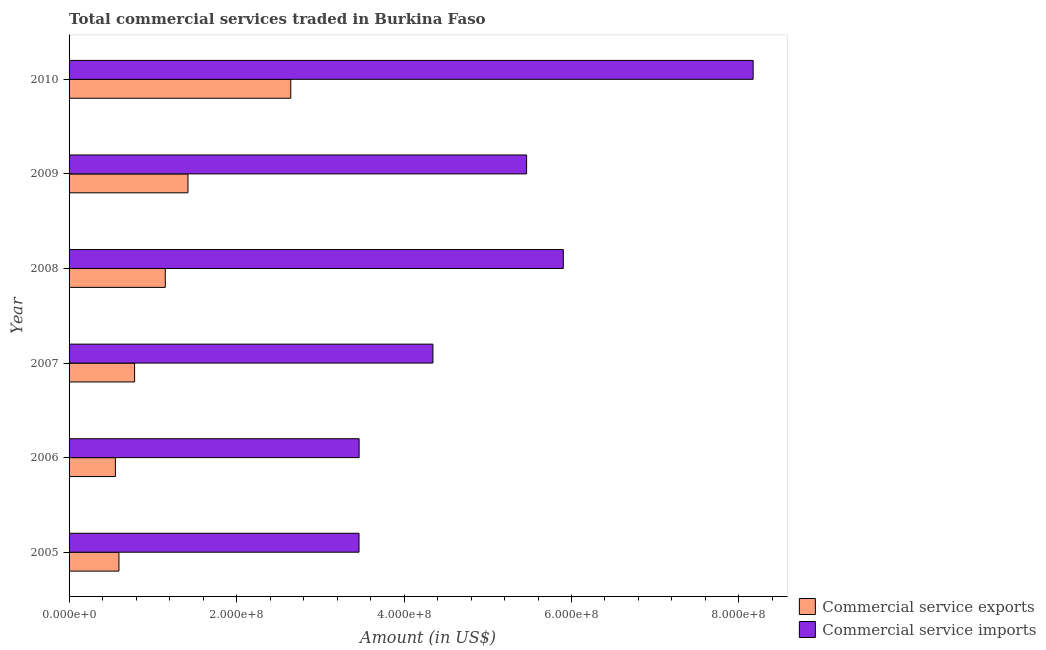How many different coloured bars are there?
Keep it short and to the point. 2. Are the number of bars per tick equal to the number of legend labels?
Your response must be concise. Yes. How many bars are there on the 3rd tick from the bottom?
Your response must be concise. 2. What is the label of the 6th group of bars from the top?
Offer a very short reply. 2005. In how many cases, is the number of bars for a given year not equal to the number of legend labels?
Your answer should be compact. 0. What is the amount of commercial service imports in 2006?
Your answer should be very brief. 3.46e+08. Across all years, what is the maximum amount of commercial service exports?
Ensure brevity in your answer.  2.65e+08. Across all years, what is the minimum amount of commercial service imports?
Your answer should be very brief. 3.46e+08. In which year was the amount of commercial service imports maximum?
Give a very brief answer. 2010. What is the total amount of commercial service imports in the graph?
Your response must be concise. 3.08e+09. What is the difference between the amount of commercial service imports in 2008 and that in 2009?
Your answer should be very brief. 4.38e+07. What is the difference between the amount of commercial service exports in 2008 and the amount of commercial service imports in 2005?
Your response must be concise. -2.31e+08. What is the average amount of commercial service exports per year?
Your answer should be compact. 1.19e+08. In the year 2005, what is the difference between the amount of commercial service exports and amount of commercial service imports?
Ensure brevity in your answer.  -2.87e+08. In how many years, is the amount of commercial service imports greater than 40000000 US$?
Offer a terse response. 6. What is the ratio of the amount of commercial service exports in 2007 to that in 2010?
Give a very brief answer. 0.3. What is the difference between the highest and the second highest amount of commercial service imports?
Offer a very short reply. 2.27e+08. What is the difference between the highest and the lowest amount of commercial service imports?
Keep it short and to the point. 4.71e+08. What does the 1st bar from the top in 2006 represents?
Provide a succinct answer. Commercial service imports. What does the 1st bar from the bottom in 2010 represents?
Offer a very short reply. Commercial service exports. Are all the bars in the graph horizontal?
Ensure brevity in your answer.  Yes. What is the difference between two consecutive major ticks on the X-axis?
Give a very brief answer. 2.00e+08. Does the graph contain any zero values?
Offer a very short reply. No. Where does the legend appear in the graph?
Offer a terse response. Bottom right. How many legend labels are there?
Your answer should be very brief. 2. What is the title of the graph?
Offer a very short reply. Total commercial services traded in Burkina Faso. What is the Amount (in US$) in Commercial service exports in 2005?
Your answer should be very brief. 5.95e+07. What is the Amount (in US$) in Commercial service imports in 2005?
Make the answer very short. 3.46e+08. What is the Amount (in US$) in Commercial service exports in 2006?
Your answer should be very brief. 5.53e+07. What is the Amount (in US$) in Commercial service imports in 2006?
Offer a very short reply. 3.46e+08. What is the Amount (in US$) of Commercial service exports in 2007?
Your answer should be very brief. 7.83e+07. What is the Amount (in US$) in Commercial service imports in 2007?
Your answer should be very brief. 4.35e+08. What is the Amount (in US$) in Commercial service exports in 2008?
Your response must be concise. 1.15e+08. What is the Amount (in US$) of Commercial service imports in 2008?
Ensure brevity in your answer.  5.90e+08. What is the Amount (in US$) of Commercial service exports in 2009?
Provide a succinct answer. 1.42e+08. What is the Amount (in US$) in Commercial service imports in 2009?
Offer a terse response. 5.46e+08. What is the Amount (in US$) of Commercial service exports in 2010?
Ensure brevity in your answer.  2.65e+08. What is the Amount (in US$) of Commercial service imports in 2010?
Ensure brevity in your answer.  8.17e+08. Across all years, what is the maximum Amount (in US$) in Commercial service exports?
Offer a very short reply. 2.65e+08. Across all years, what is the maximum Amount (in US$) of Commercial service imports?
Offer a terse response. 8.17e+08. Across all years, what is the minimum Amount (in US$) in Commercial service exports?
Provide a short and direct response. 5.53e+07. Across all years, what is the minimum Amount (in US$) in Commercial service imports?
Provide a succinct answer. 3.46e+08. What is the total Amount (in US$) of Commercial service exports in the graph?
Ensure brevity in your answer.  7.15e+08. What is the total Amount (in US$) of Commercial service imports in the graph?
Give a very brief answer. 3.08e+09. What is the difference between the Amount (in US$) of Commercial service exports in 2005 and that in 2006?
Offer a very short reply. 4.23e+06. What is the difference between the Amount (in US$) in Commercial service imports in 2005 and that in 2006?
Make the answer very short. -1.38e+05. What is the difference between the Amount (in US$) of Commercial service exports in 2005 and that in 2007?
Offer a very short reply. -1.87e+07. What is the difference between the Amount (in US$) of Commercial service imports in 2005 and that in 2007?
Provide a short and direct response. -8.83e+07. What is the difference between the Amount (in US$) in Commercial service exports in 2005 and that in 2008?
Your answer should be very brief. -5.54e+07. What is the difference between the Amount (in US$) in Commercial service imports in 2005 and that in 2008?
Your response must be concise. -2.44e+08. What is the difference between the Amount (in US$) of Commercial service exports in 2005 and that in 2009?
Offer a very short reply. -8.24e+07. What is the difference between the Amount (in US$) in Commercial service imports in 2005 and that in 2009?
Ensure brevity in your answer.  -2.00e+08. What is the difference between the Amount (in US$) of Commercial service exports in 2005 and that in 2010?
Your answer should be very brief. -2.05e+08. What is the difference between the Amount (in US$) in Commercial service imports in 2005 and that in 2010?
Make the answer very short. -4.71e+08. What is the difference between the Amount (in US$) of Commercial service exports in 2006 and that in 2007?
Keep it short and to the point. -2.29e+07. What is the difference between the Amount (in US$) of Commercial service imports in 2006 and that in 2007?
Offer a very short reply. -8.81e+07. What is the difference between the Amount (in US$) of Commercial service exports in 2006 and that in 2008?
Ensure brevity in your answer.  -5.96e+07. What is the difference between the Amount (in US$) in Commercial service imports in 2006 and that in 2008?
Your response must be concise. -2.44e+08. What is the difference between the Amount (in US$) in Commercial service exports in 2006 and that in 2009?
Give a very brief answer. -8.67e+07. What is the difference between the Amount (in US$) of Commercial service imports in 2006 and that in 2009?
Offer a very short reply. -2.00e+08. What is the difference between the Amount (in US$) of Commercial service exports in 2006 and that in 2010?
Give a very brief answer. -2.09e+08. What is the difference between the Amount (in US$) in Commercial service imports in 2006 and that in 2010?
Your response must be concise. -4.71e+08. What is the difference between the Amount (in US$) of Commercial service exports in 2007 and that in 2008?
Your answer should be compact. -3.66e+07. What is the difference between the Amount (in US$) of Commercial service imports in 2007 and that in 2008?
Your answer should be very brief. -1.56e+08. What is the difference between the Amount (in US$) in Commercial service exports in 2007 and that in 2009?
Your answer should be very brief. -6.37e+07. What is the difference between the Amount (in US$) of Commercial service imports in 2007 and that in 2009?
Keep it short and to the point. -1.12e+08. What is the difference between the Amount (in US$) of Commercial service exports in 2007 and that in 2010?
Keep it short and to the point. -1.87e+08. What is the difference between the Amount (in US$) in Commercial service imports in 2007 and that in 2010?
Ensure brevity in your answer.  -3.82e+08. What is the difference between the Amount (in US$) in Commercial service exports in 2008 and that in 2009?
Keep it short and to the point. -2.71e+07. What is the difference between the Amount (in US$) of Commercial service imports in 2008 and that in 2009?
Make the answer very short. 4.38e+07. What is the difference between the Amount (in US$) in Commercial service exports in 2008 and that in 2010?
Offer a terse response. -1.50e+08. What is the difference between the Amount (in US$) in Commercial service imports in 2008 and that in 2010?
Offer a terse response. -2.27e+08. What is the difference between the Amount (in US$) of Commercial service exports in 2009 and that in 2010?
Keep it short and to the point. -1.23e+08. What is the difference between the Amount (in US$) of Commercial service imports in 2009 and that in 2010?
Give a very brief answer. -2.71e+08. What is the difference between the Amount (in US$) in Commercial service exports in 2005 and the Amount (in US$) in Commercial service imports in 2006?
Your answer should be very brief. -2.87e+08. What is the difference between the Amount (in US$) of Commercial service exports in 2005 and the Amount (in US$) of Commercial service imports in 2007?
Offer a very short reply. -3.75e+08. What is the difference between the Amount (in US$) in Commercial service exports in 2005 and the Amount (in US$) in Commercial service imports in 2008?
Your response must be concise. -5.31e+08. What is the difference between the Amount (in US$) in Commercial service exports in 2005 and the Amount (in US$) in Commercial service imports in 2009?
Provide a succinct answer. -4.87e+08. What is the difference between the Amount (in US$) in Commercial service exports in 2005 and the Amount (in US$) in Commercial service imports in 2010?
Your answer should be compact. -7.57e+08. What is the difference between the Amount (in US$) in Commercial service exports in 2006 and the Amount (in US$) in Commercial service imports in 2007?
Offer a terse response. -3.79e+08. What is the difference between the Amount (in US$) of Commercial service exports in 2006 and the Amount (in US$) of Commercial service imports in 2008?
Keep it short and to the point. -5.35e+08. What is the difference between the Amount (in US$) in Commercial service exports in 2006 and the Amount (in US$) in Commercial service imports in 2009?
Your answer should be compact. -4.91e+08. What is the difference between the Amount (in US$) in Commercial service exports in 2006 and the Amount (in US$) in Commercial service imports in 2010?
Your answer should be compact. -7.62e+08. What is the difference between the Amount (in US$) in Commercial service exports in 2007 and the Amount (in US$) in Commercial service imports in 2008?
Give a very brief answer. -5.12e+08. What is the difference between the Amount (in US$) of Commercial service exports in 2007 and the Amount (in US$) of Commercial service imports in 2009?
Provide a succinct answer. -4.68e+08. What is the difference between the Amount (in US$) of Commercial service exports in 2007 and the Amount (in US$) of Commercial service imports in 2010?
Ensure brevity in your answer.  -7.39e+08. What is the difference between the Amount (in US$) in Commercial service exports in 2008 and the Amount (in US$) in Commercial service imports in 2009?
Keep it short and to the point. -4.32e+08. What is the difference between the Amount (in US$) of Commercial service exports in 2008 and the Amount (in US$) of Commercial service imports in 2010?
Provide a succinct answer. -7.02e+08. What is the difference between the Amount (in US$) of Commercial service exports in 2009 and the Amount (in US$) of Commercial service imports in 2010?
Offer a terse response. -6.75e+08. What is the average Amount (in US$) of Commercial service exports per year?
Your answer should be compact. 1.19e+08. What is the average Amount (in US$) in Commercial service imports per year?
Ensure brevity in your answer.  5.13e+08. In the year 2005, what is the difference between the Amount (in US$) of Commercial service exports and Amount (in US$) of Commercial service imports?
Your response must be concise. -2.87e+08. In the year 2006, what is the difference between the Amount (in US$) in Commercial service exports and Amount (in US$) in Commercial service imports?
Your answer should be very brief. -2.91e+08. In the year 2007, what is the difference between the Amount (in US$) of Commercial service exports and Amount (in US$) of Commercial service imports?
Give a very brief answer. -3.56e+08. In the year 2008, what is the difference between the Amount (in US$) in Commercial service exports and Amount (in US$) in Commercial service imports?
Provide a succinct answer. -4.75e+08. In the year 2009, what is the difference between the Amount (in US$) in Commercial service exports and Amount (in US$) in Commercial service imports?
Your answer should be compact. -4.04e+08. In the year 2010, what is the difference between the Amount (in US$) of Commercial service exports and Amount (in US$) of Commercial service imports?
Your answer should be very brief. -5.52e+08. What is the ratio of the Amount (in US$) in Commercial service exports in 2005 to that in 2006?
Your answer should be compact. 1.08. What is the ratio of the Amount (in US$) of Commercial service exports in 2005 to that in 2007?
Your answer should be very brief. 0.76. What is the ratio of the Amount (in US$) in Commercial service imports in 2005 to that in 2007?
Give a very brief answer. 0.8. What is the ratio of the Amount (in US$) in Commercial service exports in 2005 to that in 2008?
Your answer should be very brief. 0.52. What is the ratio of the Amount (in US$) of Commercial service imports in 2005 to that in 2008?
Provide a short and direct response. 0.59. What is the ratio of the Amount (in US$) of Commercial service exports in 2005 to that in 2009?
Your answer should be compact. 0.42. What is the ratio of the Amount (in US$) of Commercial service imports in 2005 to that in 2009?
Offer a terse response. 0.63. What is the ratio of the Amount (in US$) of Commercial service exports in 2005 to that in 2010?
Give a very brief answer. 0.22. What is the ratio of the Amount (in US$) in Commercial service imports in 2005 to that in 2010?
Make the answer very short. 0.42. What is the ratio of the Amount (in US$) in Commercial service exports in 2006 to that in 2007?
Your response must be concise. 0.71. What is the ratio of the Amount (in US$) of Commercial service imports in 2006 to that in 2007?
Provide a short and direct response. 0.8. What is the ratio of the Amount (in US$) of Commercial service exports in 2006 to that in 2008?
Provide a short and direct response. 0.48. What is the ratio of the Amount (in US$) of Commercial service imports in 2006 to that in 2008?
Offer a terse response. 0.59. What is the ratio of the Amount (in US$) in Commercial service exports in 2006 to that in 2009?
Provide a short and direct response. 0.39. What is the ratio of the Amount (in US$) of Commercial service imports in 2006 to that in 2009?
Ensure brevity in your answer.  0.63. What is the ratio of the Amount (in US$) of Commercial service exports in 2006 to that in 2010?
Your response must be concise. 0.21. What is the ratio of the Amount (in US$) of Commercial service imports in 2006 to that in 2010?
Offer a terse response. 0.42. What is the ratio of the Amount (in US$) in Commercial service exports in 2007 to that in 2008?
Provide a short and direct response. 0.68. What is the ratio of the Amount (in US$) of Commercial service imports in 2007 to that in 2008?
Offer a terse response. 0.74. What is the ratio of the Amount (in US$) in Commercial service exports in 2007 to that in 2009?
Offer a very short reply. 0.55. What is the ratio of the Amount (in US$) of Commercial service imports in 2007 to that in 2009?
Make the answer very short. 0.8. What is the ratio of the Amount (in US$) in Commercial service exports in 2007 to that in 2010?
Keep it short and to the point. 0.3. What is the ratio of the Amount (in US$) of Commercial service imports in 2007 to that in 2010?
Provide a succinct answer. 0.53. What is the ratio of the Amount (in US$) in Commercial service exports in 2008 to that in 2009?
Your answer should be very brief. 0.81. What is the ratio of the Amount (in US$) of Commercial service imports in 2008 to that in 2009?
Give a very brief answer. 1.08. What is the ratio of the Amount (in US$) of Commercial service exports in 2008 to that in 2010?
Provide a succinct answer. 0.43. What is the ratio of the Amount (in US$) in Commercial service imports in 2008 to that in 2010?
Your answer should be compact. 0.72. What is the ratio of the Amount (in US$) of Commercial service exports in 2009 to that in 2010?
Offer a terse response. 0.54. What is the ratio of the Amount (in US$) in Commercial service imports in 2009 to that in 2010?
Offer a terse response. 0.67. What is the difference between the highest and the second highest Amount (in US$) of Commercial service exports?
Your answer should be very brief. 1.23e+08. What is the difference between the highest and the second highest Amount (in US$) of Commercial service imports?
Provide a short and direct response. 2.27e+08. What is the difference between the highest and the lowest Amount (in US$) of Commercial service exports?
Keep it short and to the point. 2.09e+08. What is the difference between the highest and the lowest Amount (in US$) of Commercial service imports?
Give a very brief answer. 4.71e+08. 